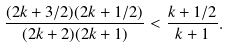<formula> <loc_0><loc_0><loc_500><loc_500>\frac { ( 2 k + 3 / 2 ) ( 2 k + 1 / 2 ) } { ( 2 k + 2 ) ( 2 k + 1 ) } < \frac { k + 1 / 2 } { k + 1 } .</formula> 